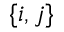<formula> <loc_0><loc_0><loc_500><loc_500>\{ i , j \}</formula> 